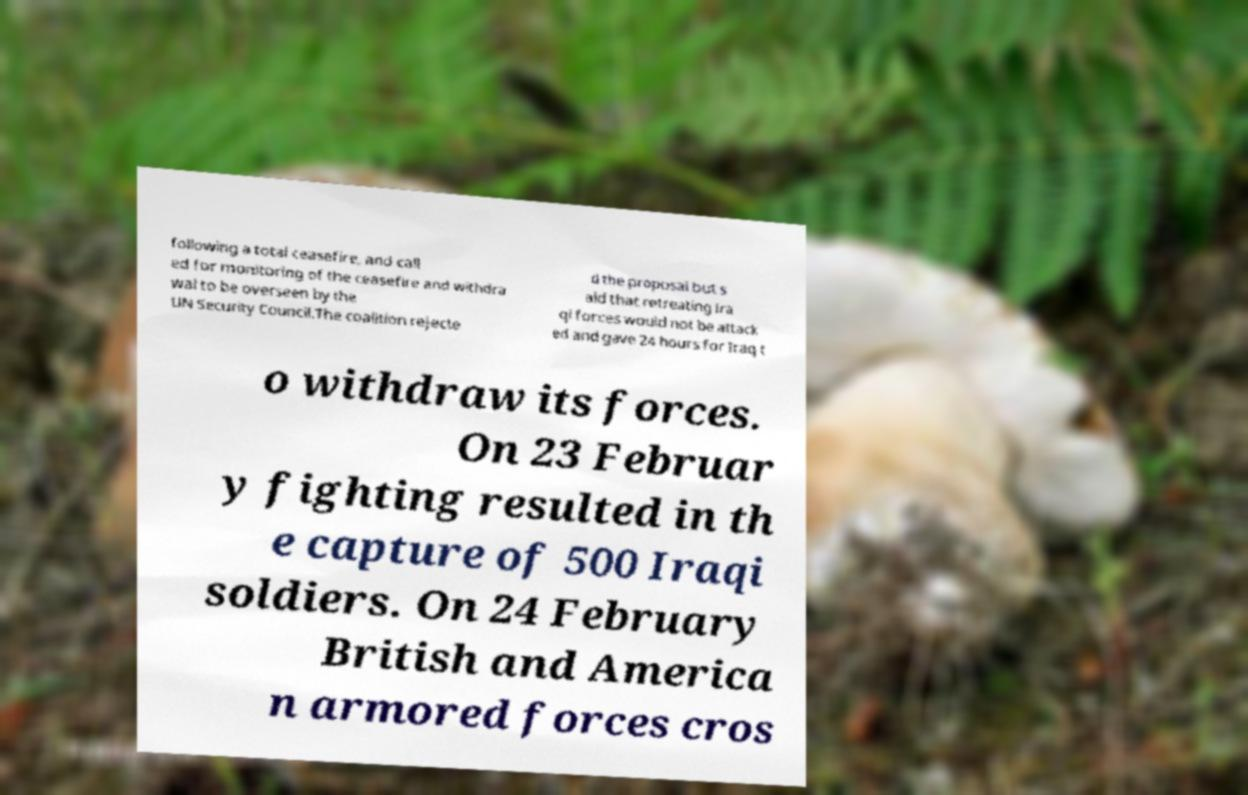Please identify and transcribe the text found in this image. following a total ceasefire, and call ed for monitoring of the ceasefire and withdra wal to be overseen by the UN Security Council.The coalition rejecte d the proposal but s aid that retreating Ira qi forces would not be attack ed and gave 24 hours for Iraq t o withdraw its forces. On 23 Februar y fighting resulted in th e capture of 500 Iraqi soldiers. On 24 February British and America n armored forces cros 